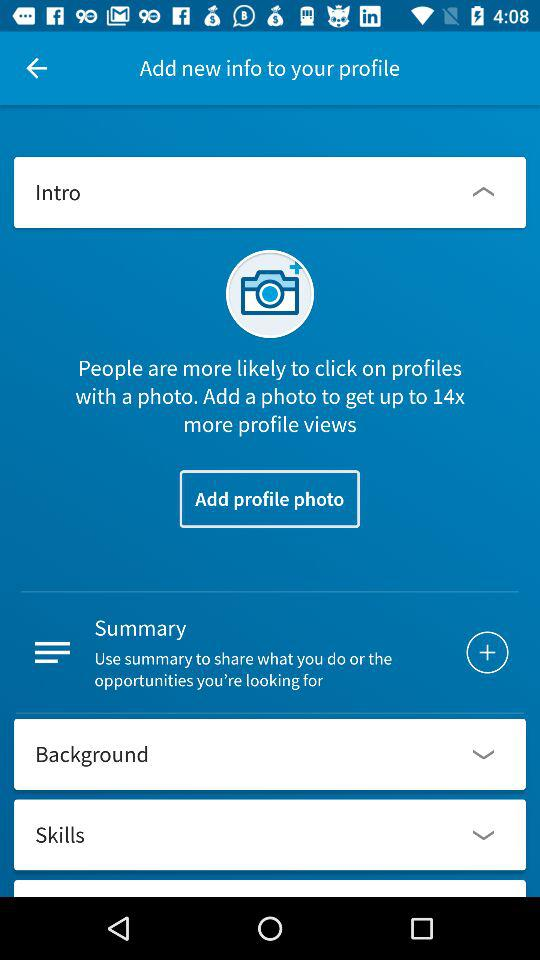How to get 14x more profile views? To get 14x more profile views, add a photo. 